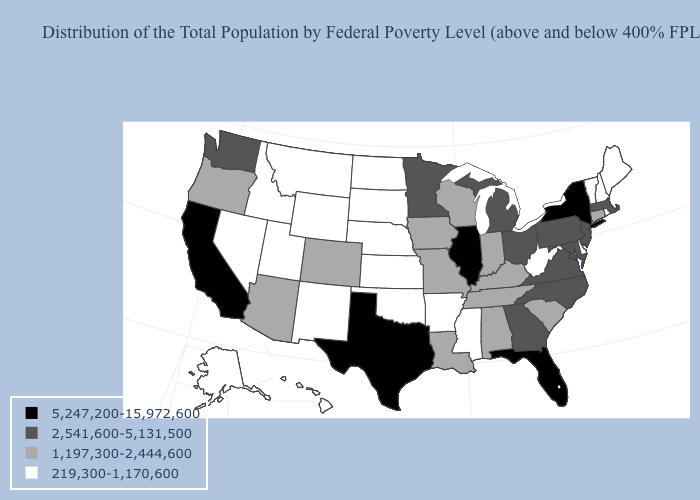Name the states that have a value in the range 1,197,300-2,444,600?
Be succinct. Alabama, Arizona, Colorado, Connecticut, Indiana, Iowa, Kentucky, Louisiana, Missouri, Oregon, South Carolina, Tennessee, Wisconsin. Name the states that have a value in the range 219,300-1,170,600?
Short answer required. Alaska, Arkansas, Delaware, Hawaii, Idaho, Kansas, Maine, Mississippi, Montana, Nebraska, Nevada, New Hampshire, New Mexico, North Dakota, Oklahoma, Rhode Island, South Dakota, Utah, Vermont, West Virginia, Wyoming. Among the states that border New Mexico , does Texas have the highest value?
Give a very brief answer. Yes. What is the highest value in the USA?
Give a very brief answer. 5,247,200-15,972,600. Among the states that border Connecticut , which have the lowest value?
Keep it brief. Rhode Island. How many symbols are there in the legend?
Give a very brief answer. 4. Does Nebraska have a higher value than Iowa?
Short answer required. No. Among the states that border Maryland , does Virginia have the lowest value?
Give a very brief answer. No. Which states have the lowest value in the MidWest?
Be succinct. Kansas, Nebraska, North Dakota, South Dakota. Which states have the lowest value in the South?
Answer briefly. Arkansas, Delaware, Mississippi, Oklahoma, West Virginia. What is the lowest value in the USA?
Keep it brief. 219,300-1,170,600. Does Utah have the highest value in the USA?
Be succinct. No. What is the value of Wisconsin?
Keep it brief. 1,197,300-2,444,600. What is the value of Wyoming?
Be succinct. 219,300-1,170,600. 